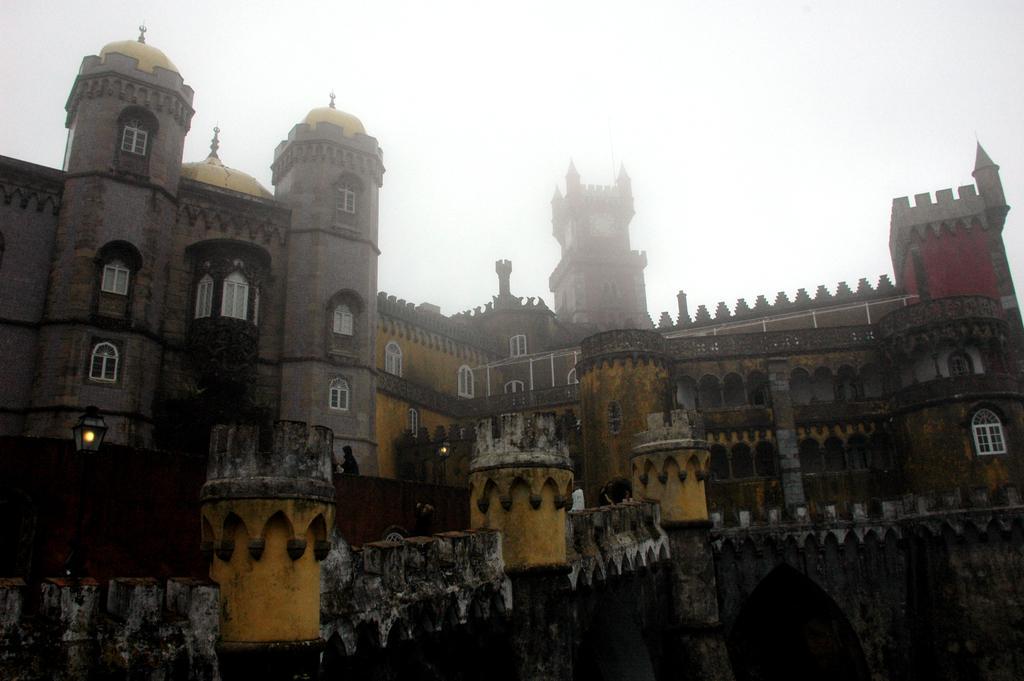Please provide a concise description of this image. This is a picture of a Pena national palace, where there are lights, poles, group of people standing, sky. 